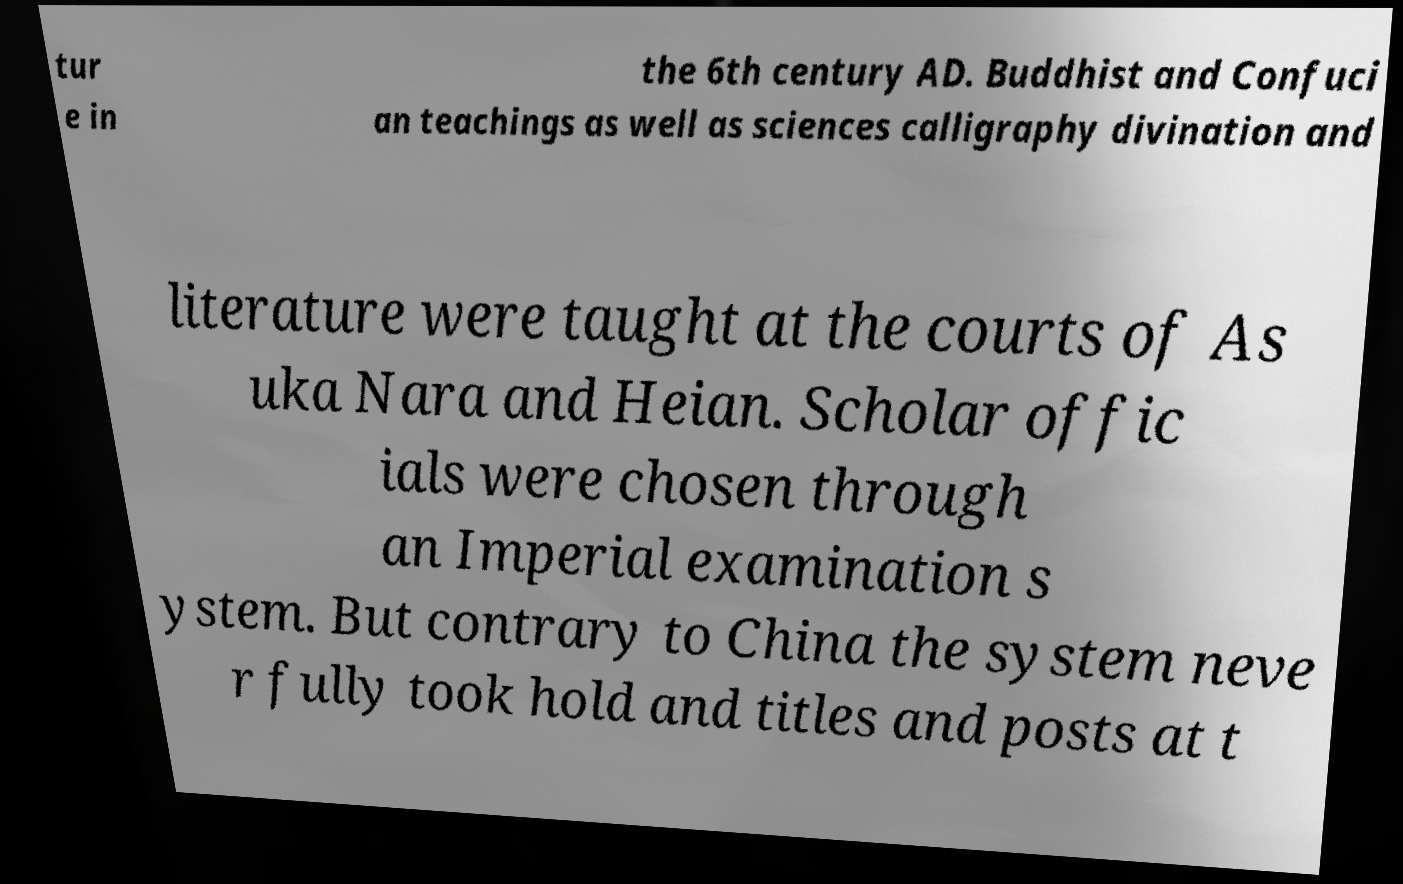For documentation purposes, I need the text within this image transcribed. Could you provide that? tur e in the 6th century AD. Buddhist and Confuci an teachings as well as sciences calligraphy divination and literature were taught at the courts of As uka Nara and Heian. Scholar offic ials were chosen through an Imperial examination s ystem. But contrary to China the system neve r fully took hold and titles and posts at t 